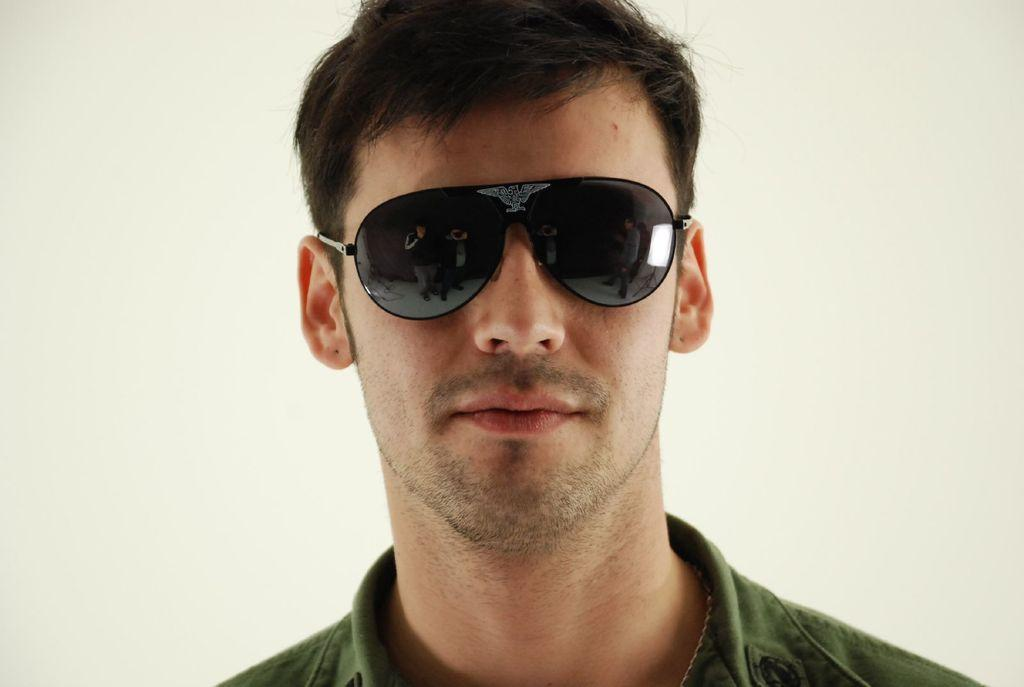Who is present in the image? There is a man in the image. What is the man wearing in the image? The man is wearing a green dress and black shades. What is the color of the background in the image? The background in the image is white. How many planes can be seen flying in the image? There are no planes visible in the image; it features a man wearing a green dress and black shades against a white background. What type of property is shown in the image? There is no property depicted in the image; it only shows a man wearing a green dress and black shades against a white background. 